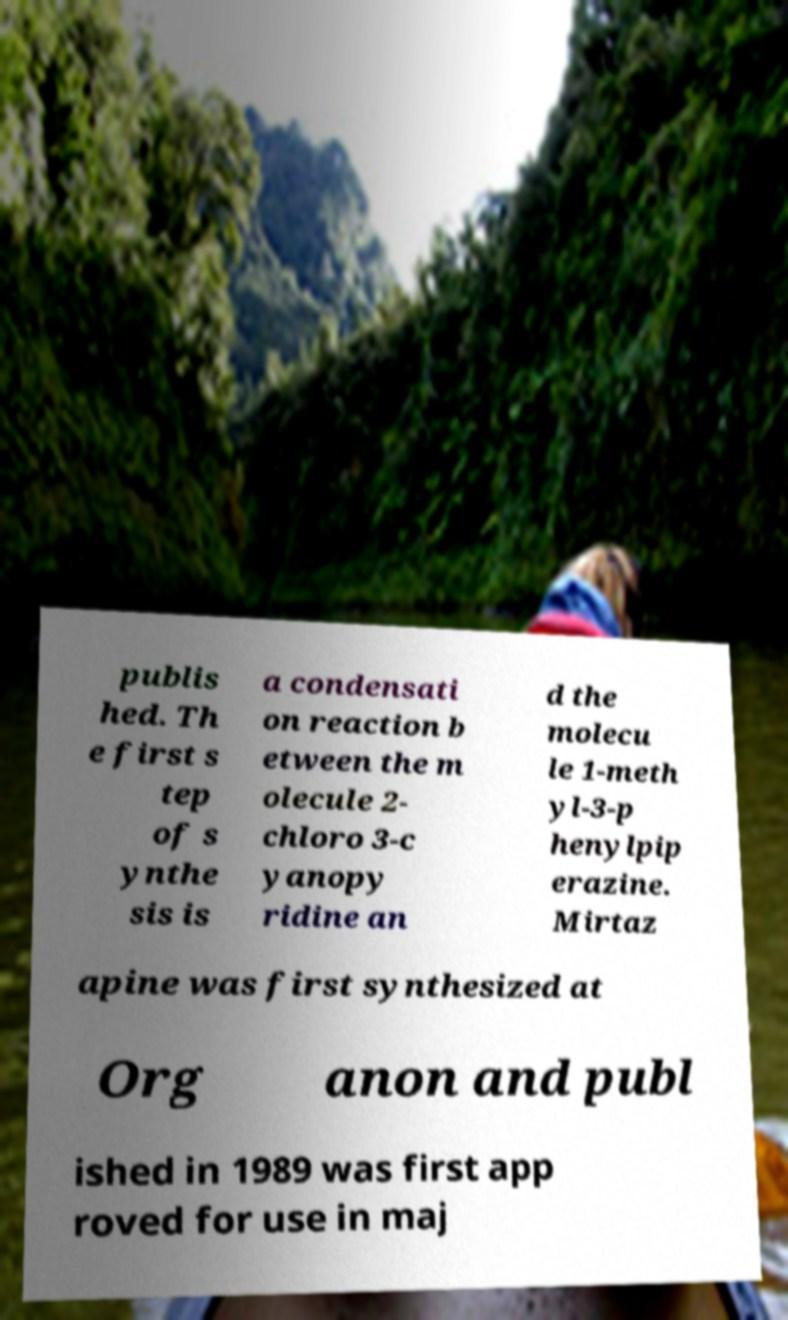What messages or text are displayed in this image? I need them in a readable, typed format. publis hed. Th e first s tep of s ynthe sis is a condensati on reaction b etween the m olecule 2- chloro 3-c yanopy ridine an d the molecu le 1-meth yl-3-p henylpip erazine. Mirtaz apine was first synthesized at Org anon and publ ished in 1989 was first app roved for use in maj 